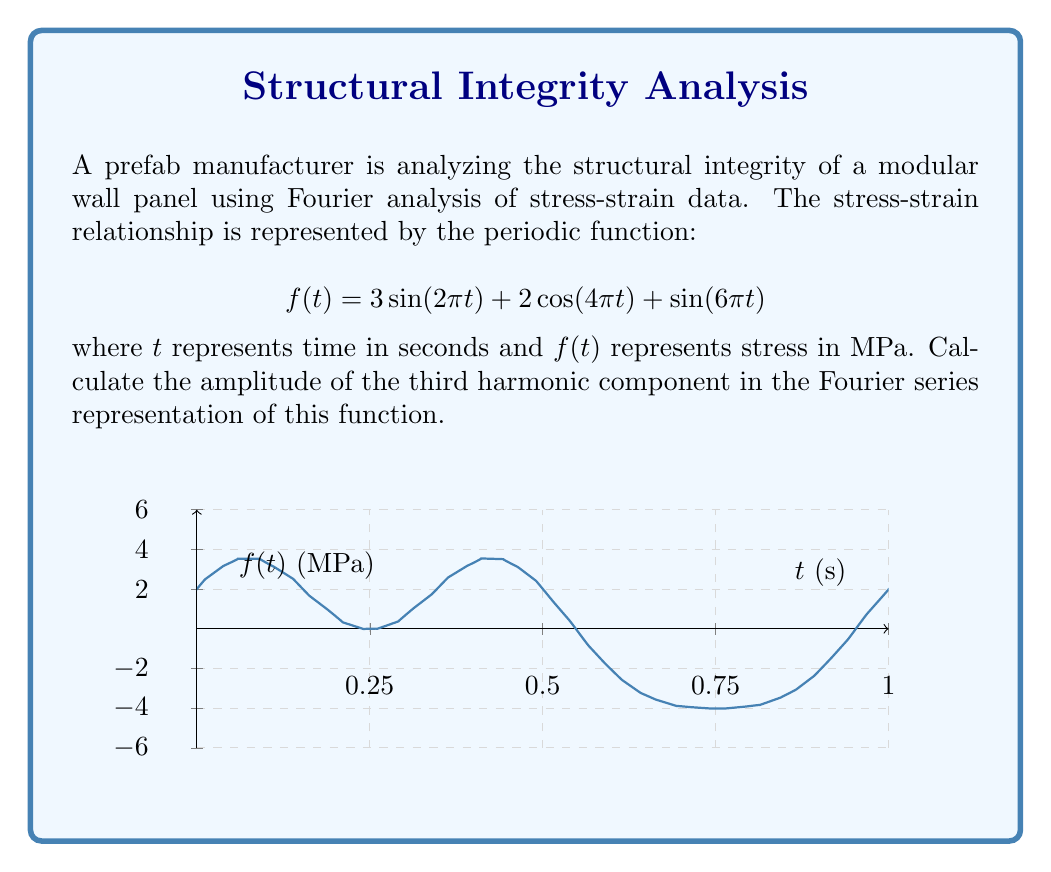Can you solve this math problem? To solve this problem, we need to identify the Fourier series components and their amplitudes:

1) The given function is already in the form of a Fourier series:
   $$f(t) = 3\sin(2\pi t) + 2\cos(4\pi t) + \sin(6\pi t)$$

2) In general, a Fourier series is represented as:
   $$f(t) = a_0 + \sum_{n=1}^{\infty} (a_n \cos(2\pi nt) + b_n \sin(2\pi nt))$$

3) Comparing our function to this general form:
   - First harmonic (n=1): $3\sin(2\pi t)$, so $b_1 = 3$
   - Second harmonic (n=2): $2\cos(4\pi t)$, so $a_2 = 2$
   - Third harmonic (n=3): $\sin(6\pi t)$, so $b_3 = 1$

4) The amplitude of each harmonic is given by $\sqrt{a_n^2 + b_n^2}$

5) For the third harmonic (n=3), we have $a_3 = 0$ and $b_3 = 1$

6) Therefore, the amplitude of the third harmonic is:
   $$\sqrt{a_3^2 + b_3^2} = \sqrt{0^2 + 1^2} = 1$$

Thus, the amplitude of the third harmonic component is 1 MPa.
Answer: 1 MPa 